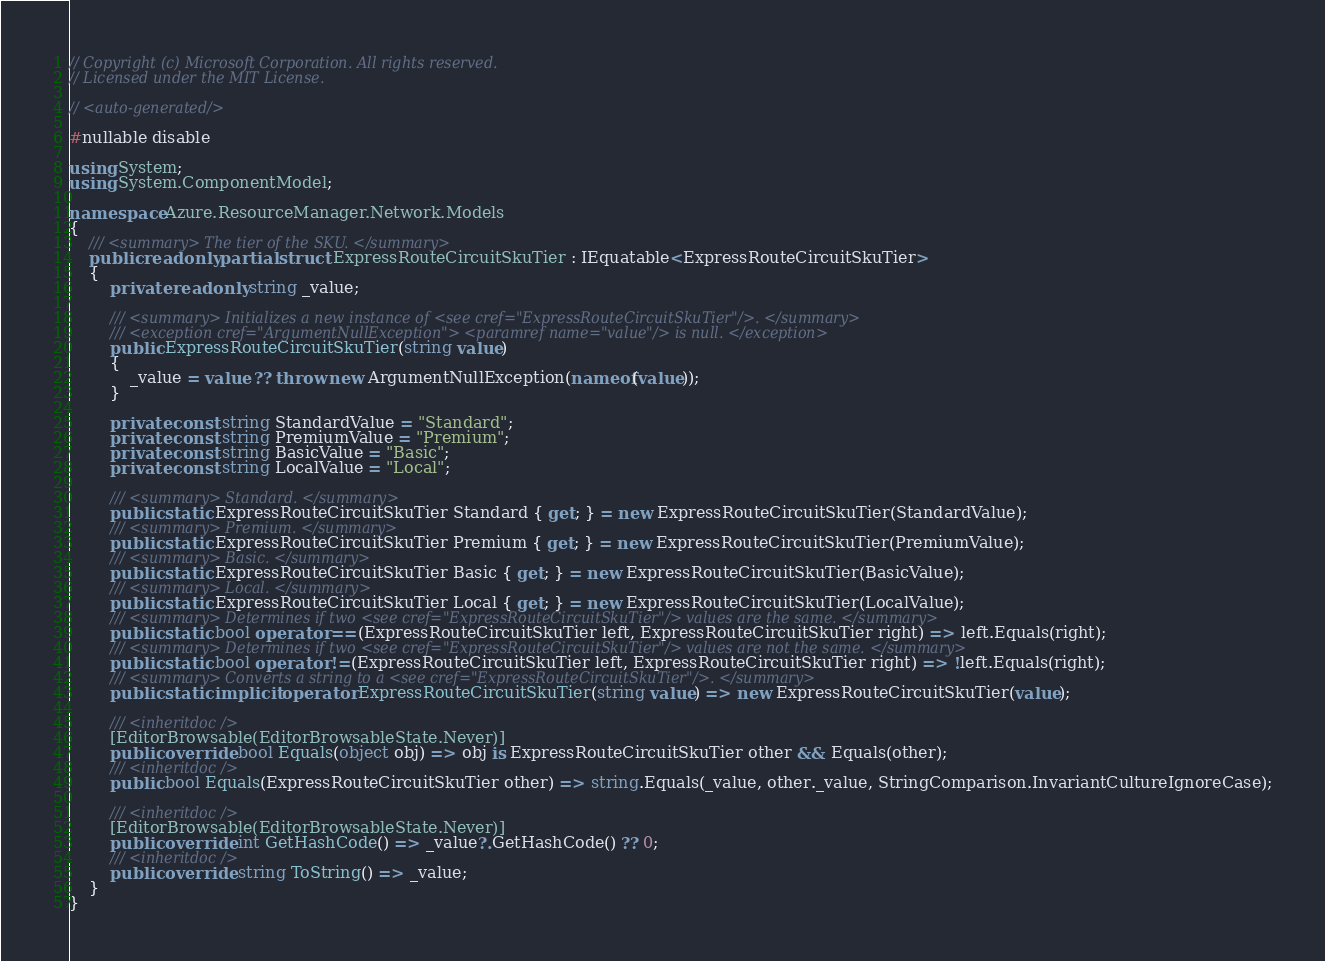Convert code to text. <code><loc_0><loc_0><loc_500><loc_500><_C#_>// Copyright (c) Microsoft Corporation. All rights reserved.
// Licensed under the MIT License.

// <auto-generated/>

#nullable disable

using System;
using System.ComponentModel;

namespace Azure.ResourceManager.Network.Models
{
    /// <summary> The tier of the SKU. </summary>
    public readonly partial struct ExpressRouteCircuitSkuTier : IEquatable<ExpressRouteCircuitSkuTier>
    {
        private readonly string _value;

        /// <summary> Initializes a new instance of <see cref="ExpressRouteCircuitSkuTier"/>. </summary>
        /// <exception cref="ArgumentNullException"> <paramref name="value"/> is null. </exception>
        public ExpressRouteCircuitSkuTier(string value)
        {
            _value = value ?? throw new ArgumentNullException(nameof(value));
        }

        private const string StandardValue = "Standard";
        private const string PremiumValue = "Premium";
        private const string BasicValue = "Basic";
        private const string LocalValue = "Local";

        /// <summary> Standard. </summary>
        public static ExpressRouteCircuitSkuTier Standard { get; } = new ExpressRouteCircuitSkuTier(StandardValue);
        /// <summary> Premium. </summary>
        public static ExpressRouteCircuitSkuTier Premium { get; } = new ExpressRouteCircuitSkuTier(PremiumValue);
        /// <summary> Basic. </summary>
        public static ExpressRouteCircuitSkuTier Basic { get; } = new ExpressRouteCircuitSkuTier(BasicValue);
        /// <summary> Local. </summary>
        public static ExpressRouteCircuitSkuTier Local { get; } = new ExpressRouteCircuitSkuTier(LocalValue);
        /// <summary> Determines if two <see cref="ExpressRouteCircuitSkuTier"/> values are the same. </summary>
        public static bool operator ==(ExpressRouteCircuitSkuTier left, ExpressRouteCircuitSkuTier right) => left.Equals(right);
        /// <summary> Determines if two <see cref="ExpressRouteCircuitSkuTier"/> values are not the same. </summary>
        public static bool operator !=(ExpressRouteCircuitSkuTier left, ExpressRouteCircuitSkuTier right) => !left.Equals(right);
        /// <summary> Converts a string to a <see cref="ExpressRouteCircuitSkuTier"/>. </summary>
        public static implicit operator ExpressRouteCircuitSkuTier(string value) => new ExpressRouteCircuitSkuTier(value);

        /// <inheritdoc />
        [EditorBrowsable(EditorBrowsableState.Never)]
        public override bool Equals(object obj) => obj is ExpressRouteCircuitSkuTier other && Equals(other);
        /// <inheritdoc />
        public bool Equals(ExpressRouteCircuitSkuTier other) => string.Equals(_value, other._value, StringComparison.InvariantCultureIgnoreCase);

        /// <inheritdoc />
        [EditorBrowsable(EditorBrowsableState.Never)]
        public override int GetHashCode() => _value?.GetHashCode() ?? 0;
        /// <inheritdoc />
        public override string ToString() => _value;
    }
}
</code> 